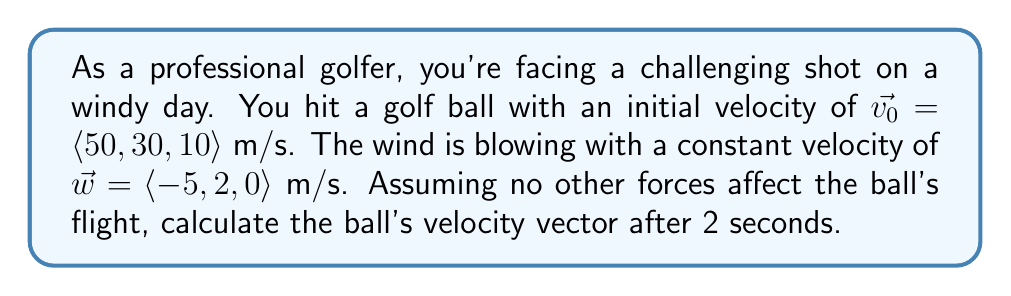Can you answer this question? To solve this problem, we need to consider the effect of wind on the golf ball's velocity. The wind will continuously affect the ball's motion throughout its flight. We can model this using vector addition.

1) The initial velocity of the ball is given as:
   $\vec{v_0} = \langle 50, 30, 10 \rangle$ m/s

2) The wind velocity is:
   $\vec{w} = \langle -5, 2, 0 \rangle$ m/s

3) The wind's effect on the ball can be modeled by adding the wind velocity to the ball's velocity for each second of flight:
   $\vec{v_t} = \vec{v_0} + t\vec{w}$
   where $t$ is the time in seconds.

4) For t = 2 seconds:
   $\vec{v_2} = \vec{v_0} + 2\vec{w}$

5) Let's calculate this step by step:
   $\vec{v_2} = \langle 50, 30, 10 \rangle + 2\langle -5, 2, 0 \rangle$
   $\vec{v_2} = \langle 50, 30, 10 \rangle + \langle -10, 4, 0 \rangle$

6) Now we add the corresponding components:
   $\vec{v_2} = \langle 50 + (-10), 30 + 4, 10 + 0 \rangle$
   $\vec{v_2} = \langle 40, 34, 10 \rangle$ m/s

Therefore, after 2 seconds, the golf ball's velocity vector will be $\langle 40, 34, 10 \rangle$ m/s.
Answer: $\vec{v_2} = \langle 40, 34, 10 \rangle$ m/s 